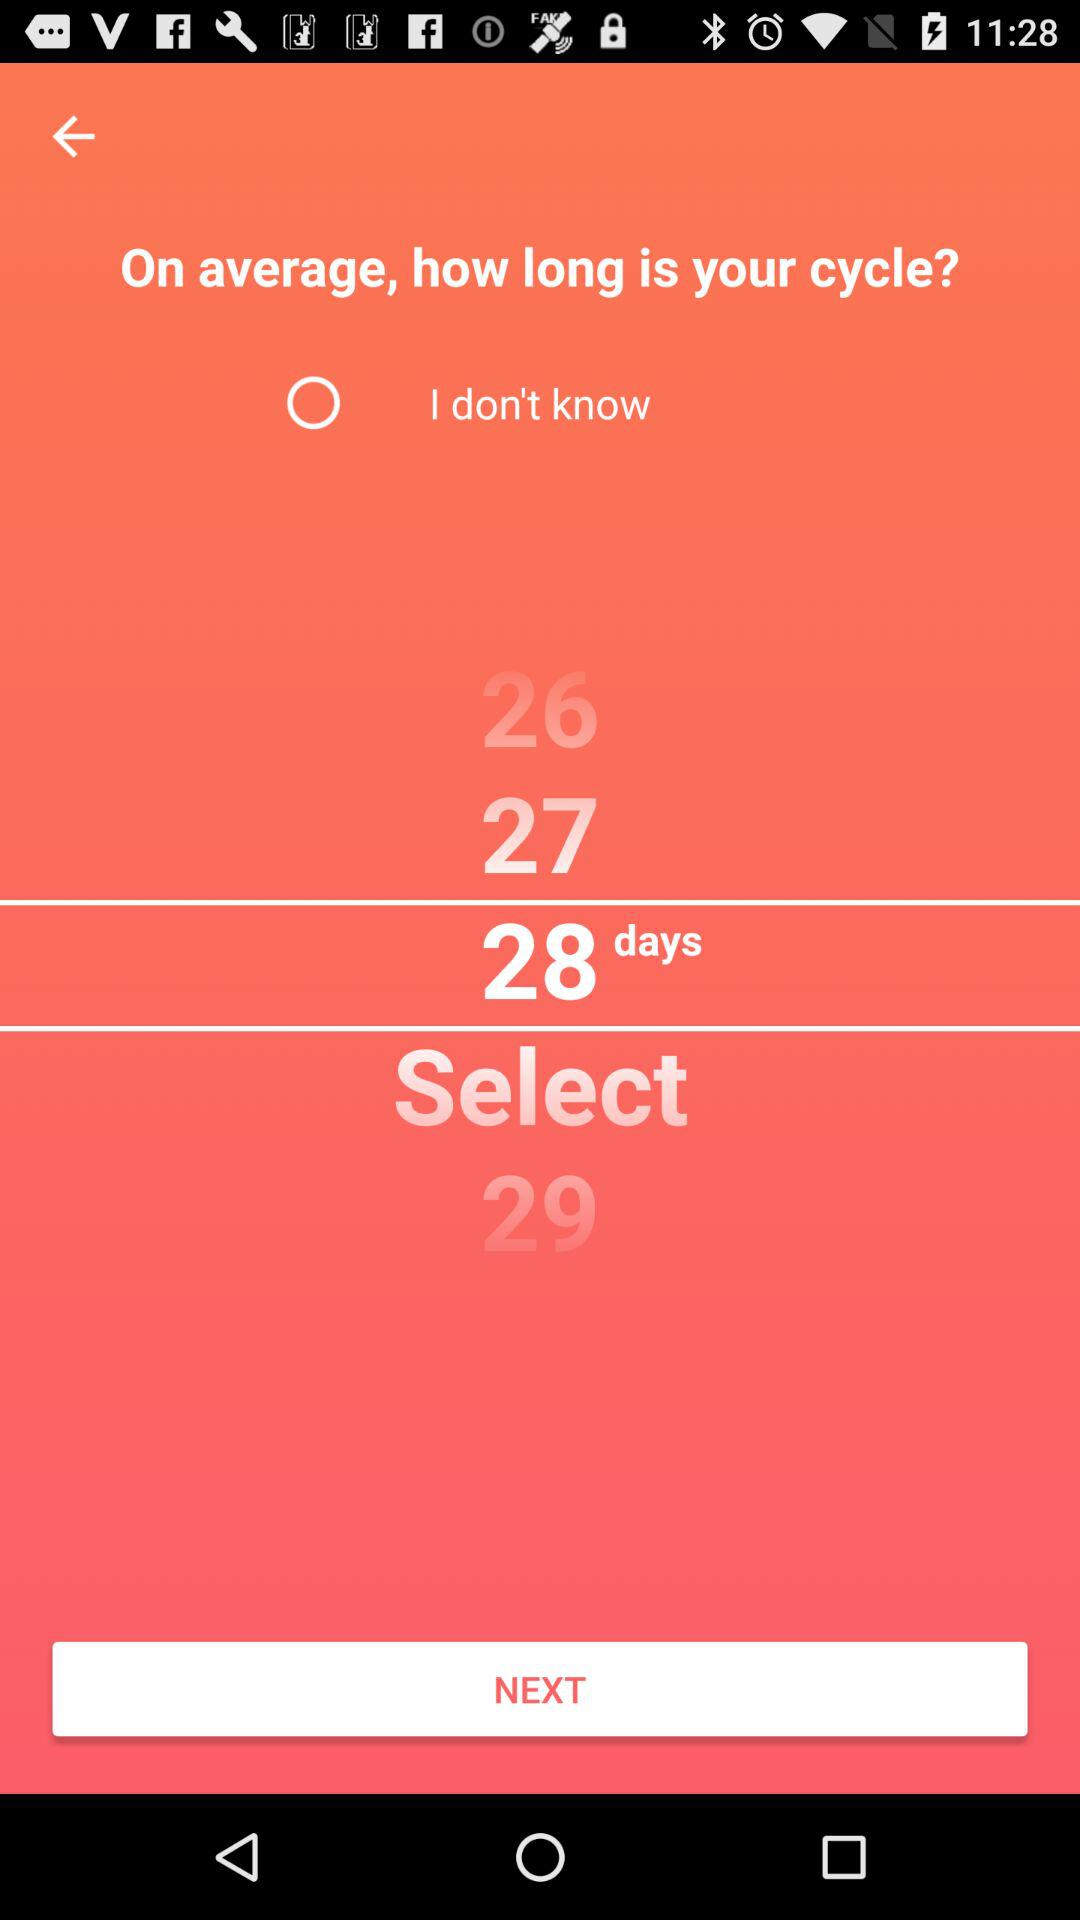What is the selected number of days? The selected number of days is 28. 